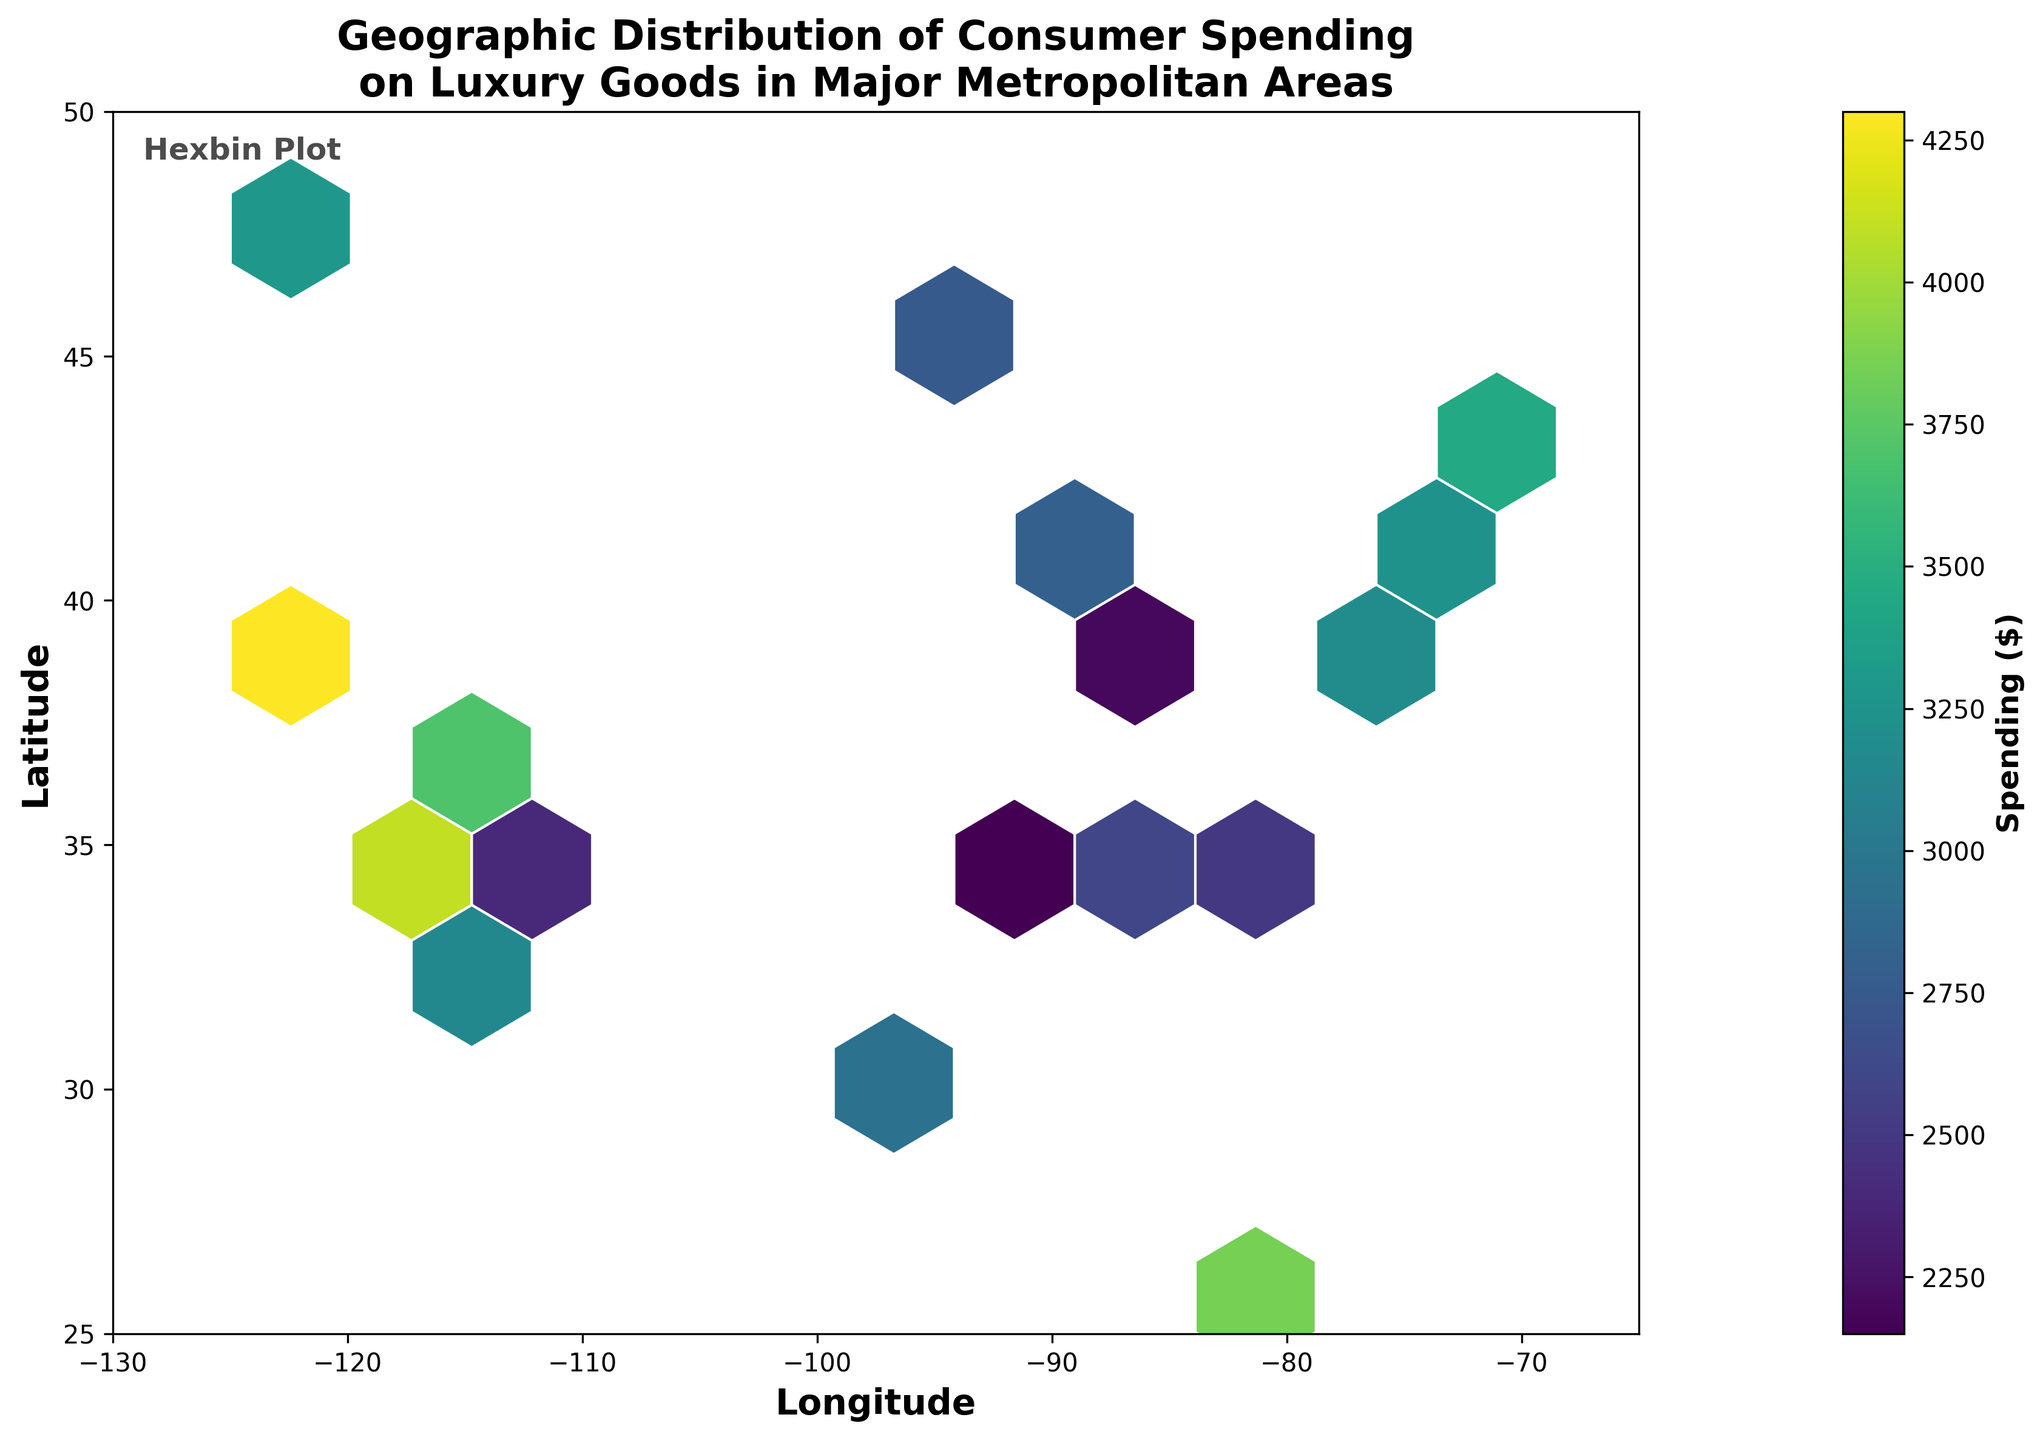What is the title of the plot? The title is shown at the top of the plot, summarizing the context in one or two lines.
Answer: Geographic Distribution of Consumer Spending on Luxury Goods in Major Metropolitan Areas What does the color bar represent? The color bar usually indicates the variable represented by the color gradations in a plot. In this context, it corresponds to spending values.
Answer: Spending ($) What are the axes labels? The x-axis label is 'Longitude' and the y-axis label is 'Latitude', indicating the geographic coordinates.
Answer: Longitude and Latitude Which city shows the highest consumer spending? We need to identify the city whose corresponding hexagon has the highest color intensity, based on the color bar.
Answer: San Francisco How many data points are represented in the plot? There are 20 points, inferred from counting the entries in the provided dataset.
Answer: 20 Which region has the densest concentration of high spending? The densest region can be identified by finding the area with the most intense and concentrated hexagons. This will be the west coast.
Answer: West Coast What is the range of the latitude shown in the plot? The latitude axis ranges between 25 and 50, as marked on the y-axis.
Answer: 25 to 50 Compare the consumer spending between New York and San Francisco. Compare the color intensity of the hexagons corresponding to the two cities to understand their spending levels. San Francisco has a higher spending compared to New York, as indicated by a more intense color.
Answer: San Francisco > New York What is the trend in consumer spending as we move from the East Coast to the West Coast? By observing the gradient in color intensity from the east side to the west side, we can infer that spending generally increases as we move westward.
Answer: Increases What is the average consumer spending in the cities plotted? Sum all the spending values and divide by the number of data points. (3250 + 4100 + 2800 + 3050 + 3450 + 2600 + 3900 + 4300 + 2950 + 3150 + 3700 + 3850 + 3300 + 2500 + 2200 + 2750 + 2400 + 2850 + 2700 + 2150) / 20 = 3209.5
Answer: 3209.5 